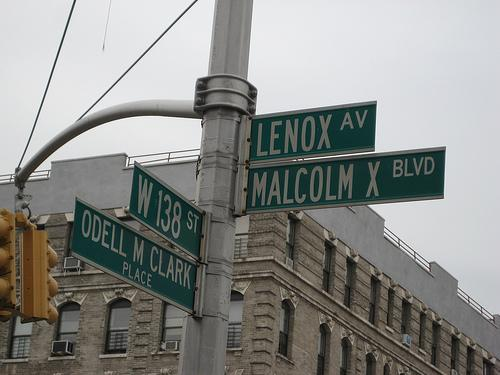Explain the unique features of the windows on the building. The windows on the building are arched, and some have metal bars and an air conditioner unit installed in them. In a sentence, describe the building's architectural style and materials. The building is made of gray stone with parapets, adorned with ornate concrete above the arched windows and a steel rail fence on the rooftop. Identify the type of fence on the roof of the building and explain its purpose. The fence on the roof is a steel rail fence, and its purpose is to protect someone from falling off the roof. Mention the key elements present on the gray metal post. The gray metal post contains several street signs, some of which are directional and green with white lettering, as well as a silver cable. Briefly describe any overhead elements in the image. Overhead elements in the image include electric wires and the arm that supports the hanging yellow street light. What are the colors of the street signs near the pole and what kind of pole is it? The street signs near the pole are green and white, and the pole is made of steel and silver in color. 